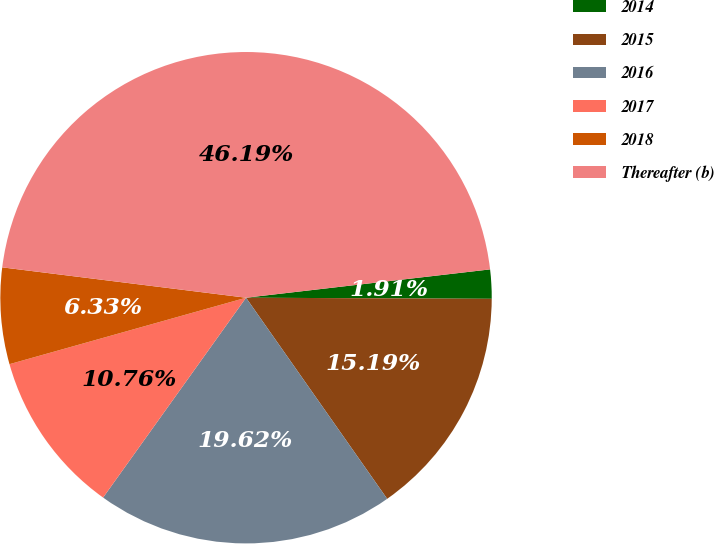Convert chart to OTSL. <chart><loc_0><loc_0><loc_500><loc_500><pie_chart><fcel>2014<fcel>2015<fcel>2016<fcel>2017<fcel>2018<fcel>Thereafter (b)<nl><fcel>1.91%<fcel>15.19%<fcel>19.62%<fcel>10.76%<fcel>6.33%<fcel>46.19%<nl></chart> 